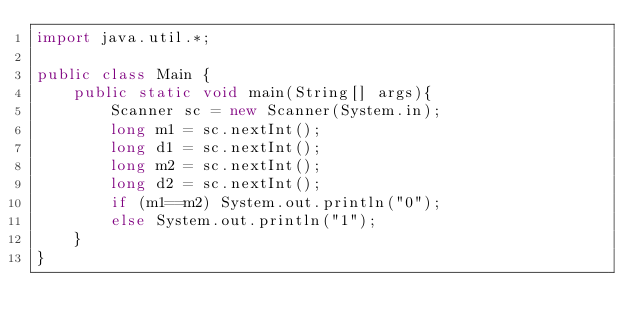<code> <loc_0><loc_0><loc_500><loc_500><_Java_>import java.util.*;

public class Main {
    public static void main(String[] args){
		Scanner sc = new Scanner(System.in);
		long m1 = sc.nextInt();
		long d1 = sc.nextInt();
		long m2 = sc.nextInt();
		long d2 = sc.nextInt();
      	if (m1==m2) System.out.println("0");
      	else System.out.println("1");
    }
}</code> 